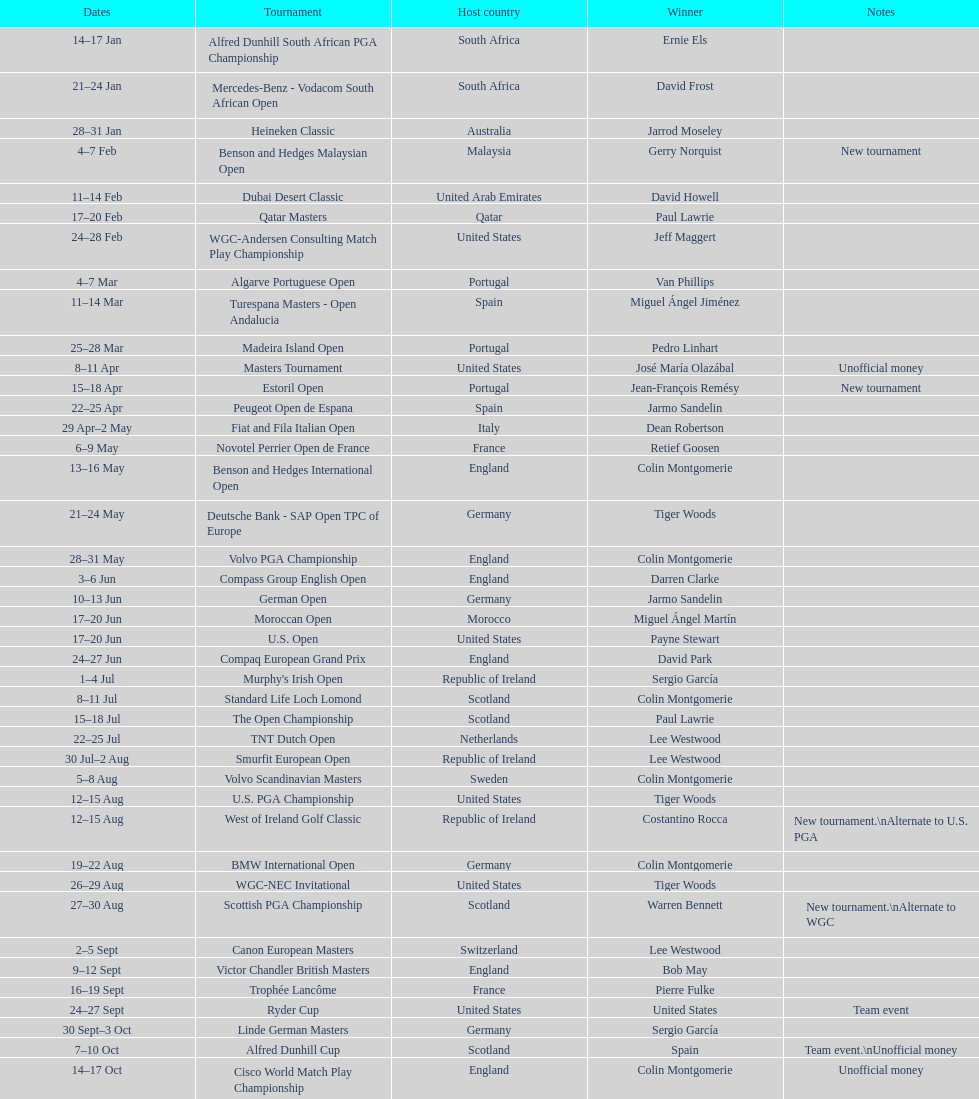How long did the estoril open last? 3 days. 